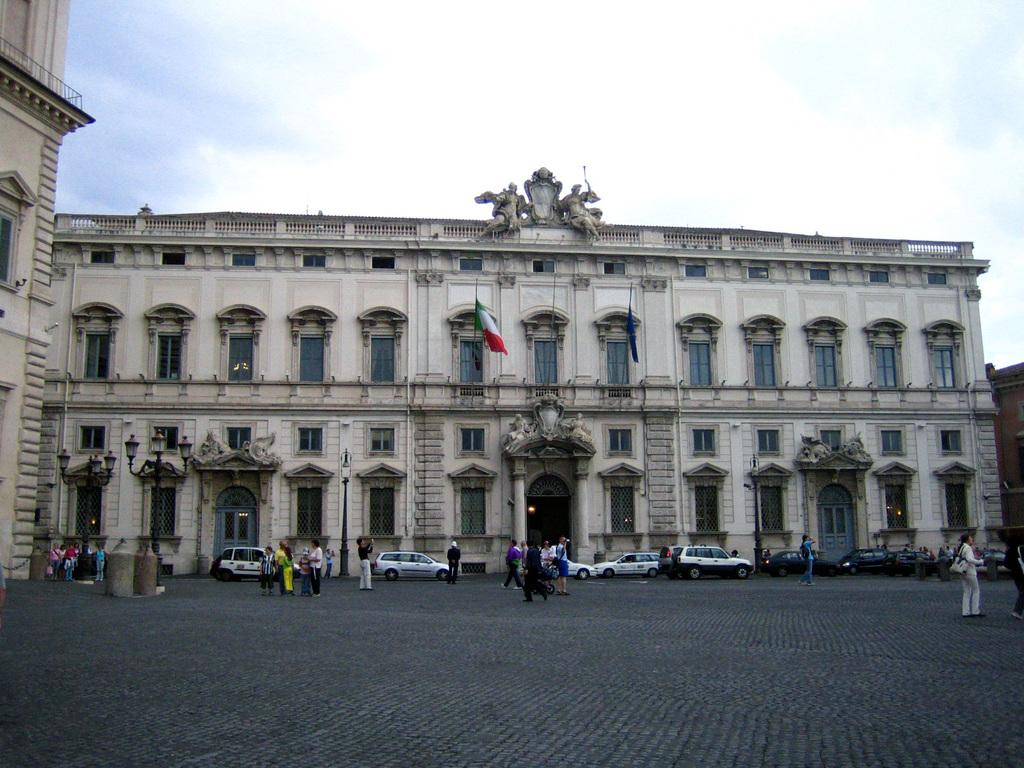How many people are the people can be seen in the image? There is a group of people standing in the image. What else is present in the image besides the people? There are vehicles, flags with poles, lights, and buildings in the image. What can be seen in the background of the image? The sky is visible in the background of the image. What type of jewel is the crow wearing in the image? There is no crow or jewel present in the image. 